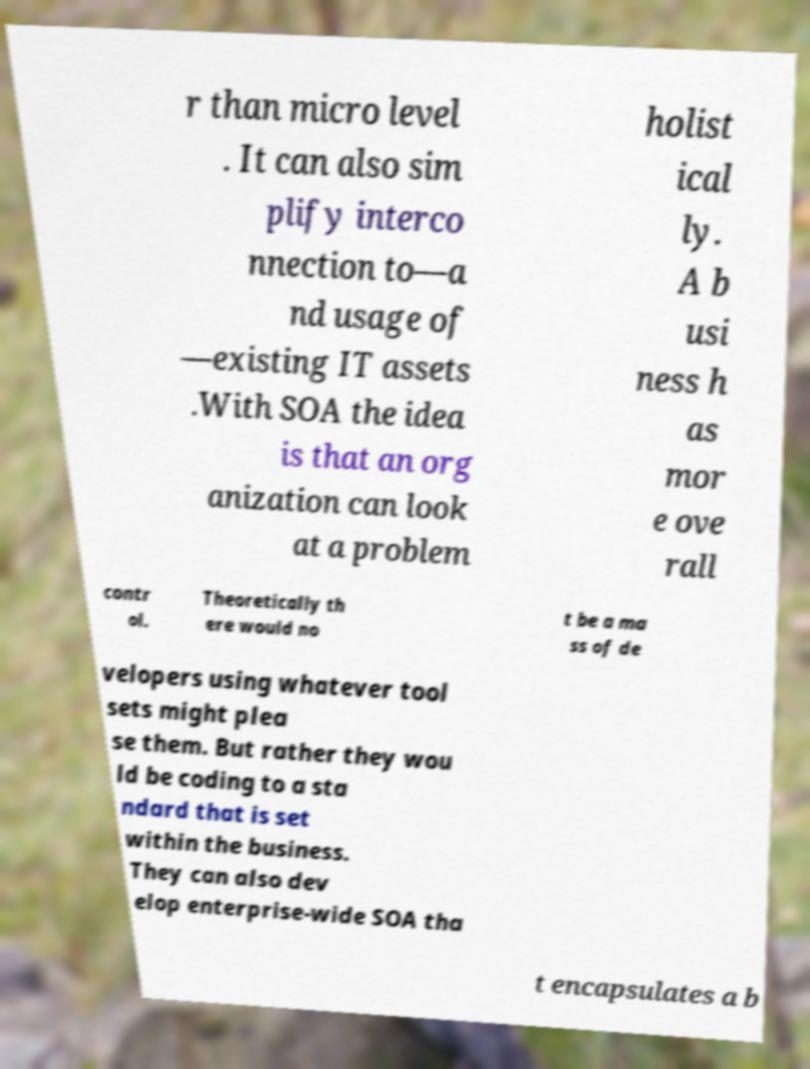For documentation purposes, I need the text within this image transcribed. Could you provide that? r than micro level . It can also sim plify interco nnection to—a nd usage of —existing IT assets .With SOA the idea is that an org anization can look at a problem holist ical ly. A b usi ness h as mor e ove rall contr ol. Theoretically th ere would no t be a ma ss of de velopers using whatever tool sets might plea se them. But rather they wou ld be coding to a sta ndard that is set within the business. They can also dev elop enterprise-wide SOA tha t encapsulates a b 